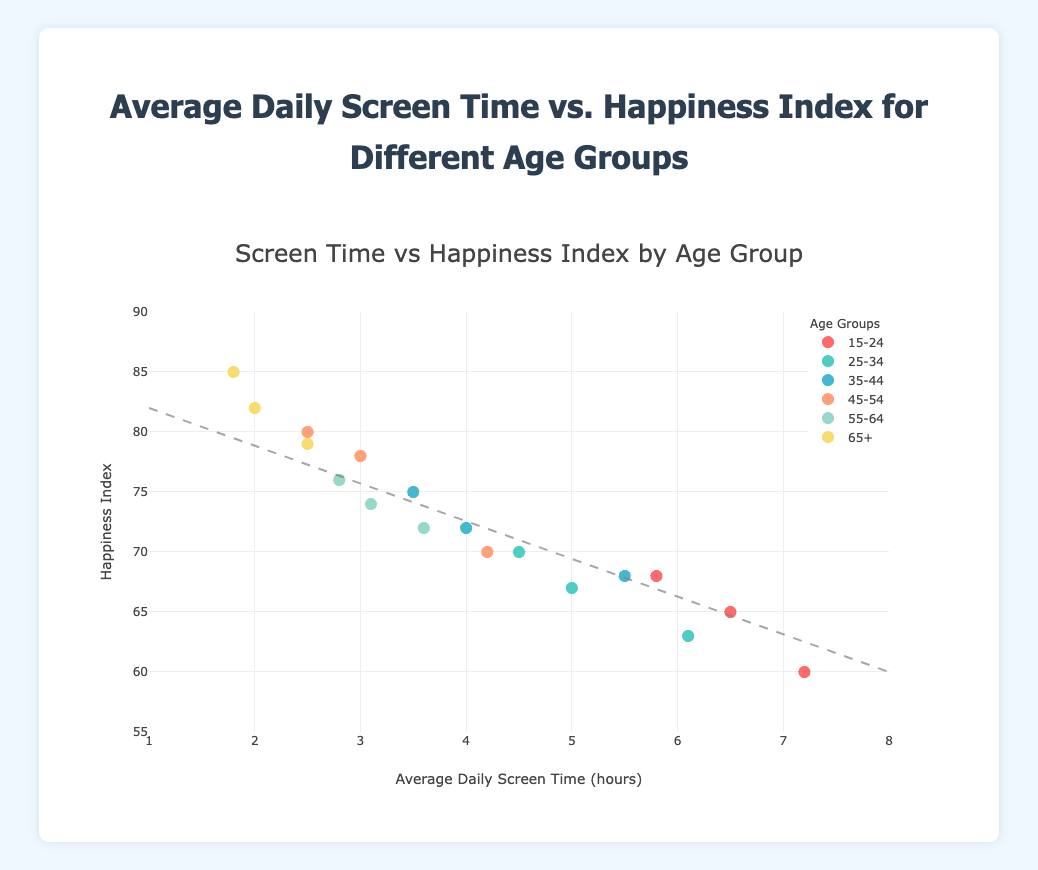What is the title of the figure? The title is usually found at the top of the figure, often in a larger or bolded font.
Answer: Average Daily Screen Time vs. Happiness Index for Different Age Groups How many age groups are represented in the plot? By looking at the legend of the plot, we can count the unique age groups listed.
Answer: 6 Which age group has the highest happiness index on average? By examining the distribution of the points in the plot and their corresponding happiness index values, we can see which age group tends to have the highest happiness index.
Answer: 65+ What is the range of the average daily screen time displayed on the x-axis? By looking at the x-axis, we can determine the minimum and maximum values. The x-axis in this figure shows values from 1 to 8 hours.
Answer: 1 to 8 hours Is there any trend observed between average daily screen time and happiness index? The plot includes a trend line which helps indicate the overall trend between the plotted variables. In this case, the trend line appears to show a negative correlation (as screen time increases, happiness index decreases).
Answer: Negative correlation Which age group shows the largest variation in average daily screen time? By observing the spread of points (horizontal width) for each age group represented in different colors, we can determine which group has the widest range of average daily screen time.
Answer: 15-24 Between which age groups do we see the smallest average screen time? By looking at the individual points for each age group and comparing, we can find which group clusters around the lower end of the x-axis.
Answer: 65+ Which age group tends to have the highest screen time? By observing the data points in the plot, the age group with the highest screen times can be identified.
Answer: 15-24 What's the range of the happiness index displayed on the y-axis? By looking at the y-axis, we can determine the minimum and maximum values displayed. The y-axis in this figure shows values from 55 to 90.
Answer: 55 to 90 In which age group is the average daily screen time below 3 hours and the happiness index above 75? By finding the points that meet these criteria and noting their corresponding age group, we can determine the specific age group(s).
Answer: 45-54, 55-64, 65+ 